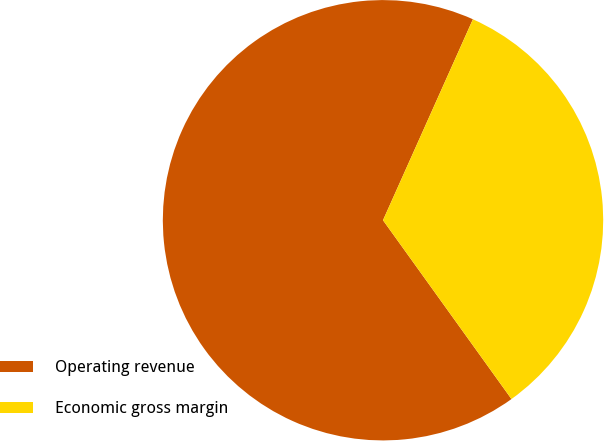Convert chart. <chart><loc_0><loc_0><loc_500><loc_500><pie_chart><fcel>Operating revenue<fcel>Economic gross margin<nl><fcel>66.61%<fcel>33.39%<nl></chart> 